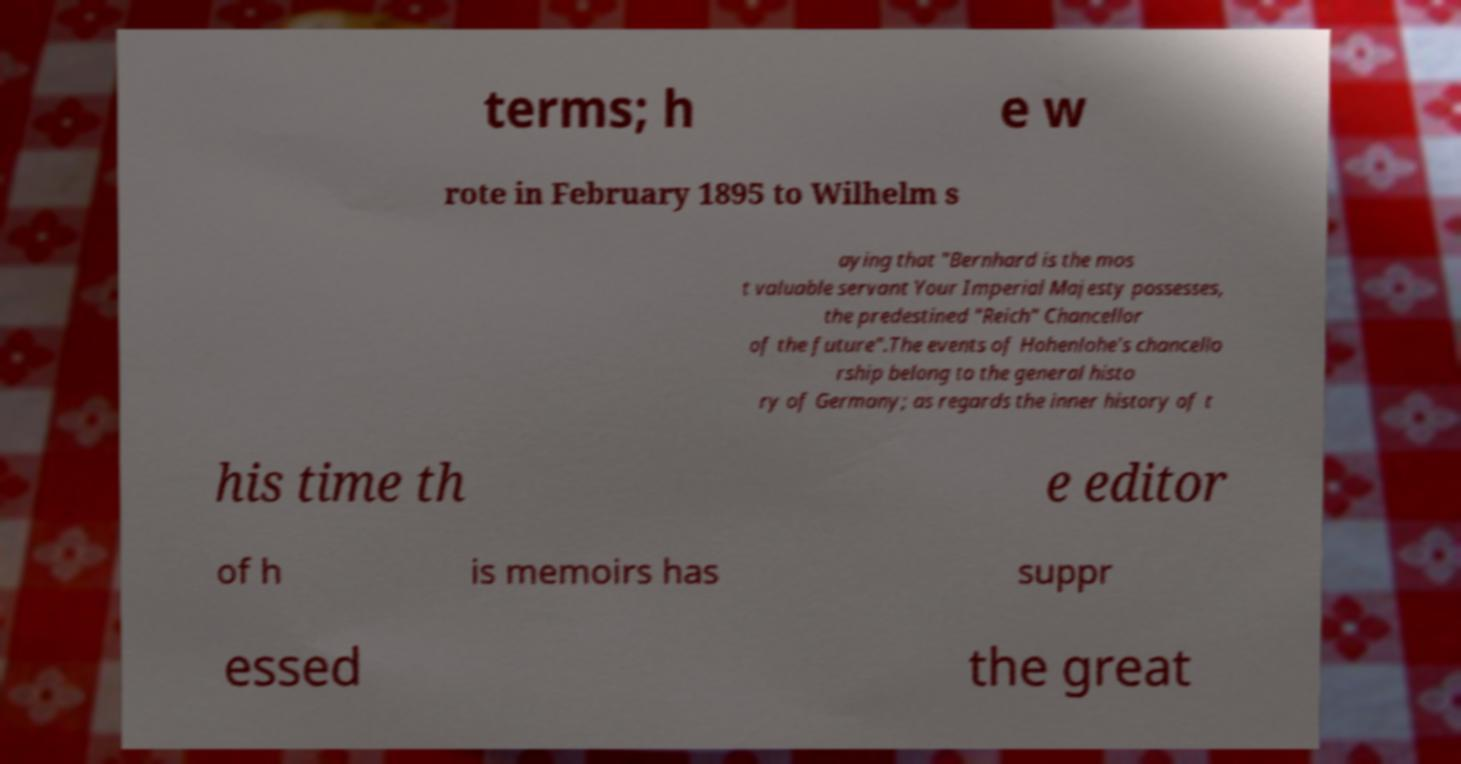Please read and relay the text visible in this image. What does it say? terms; h e w rote in February 1895 to Wilhelm s aying that "Bernhard is the mos t valuable servant Your Imperial Majesty possesses, the predestined "Reich" Chancellor of the future".The events of Hohenlohe's chancello rship belong to the general histo ry of Germany; as regards the inner history of t his time th e editor of h is memoirs has suppr essed the great 